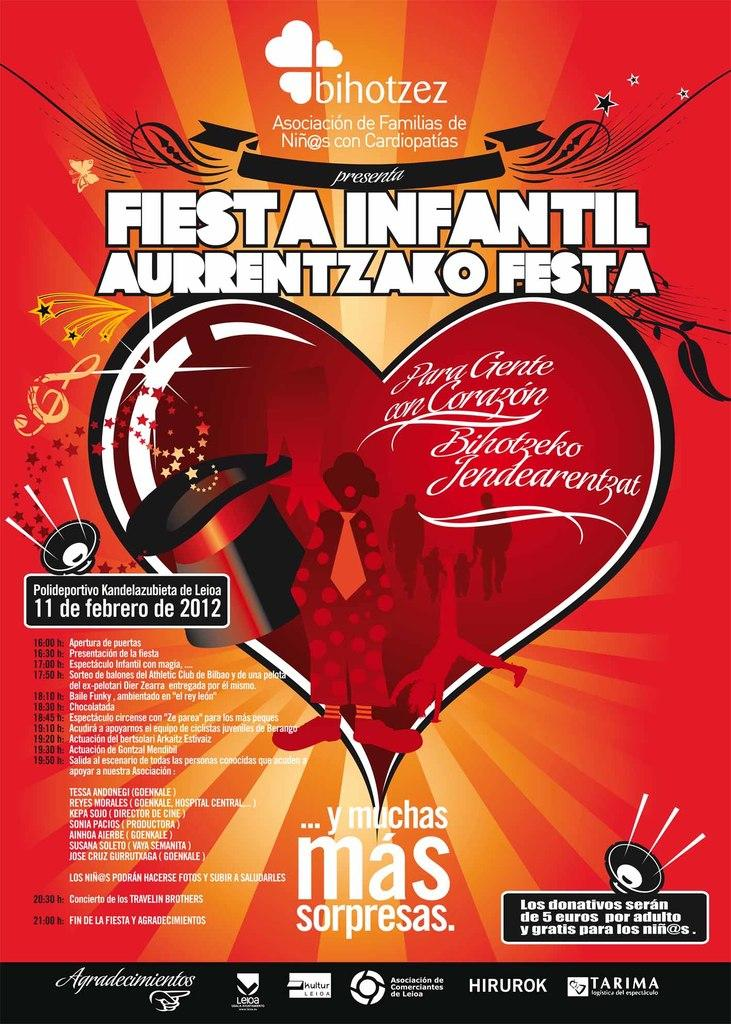<image>
Offer a succinct explanation of the picture presented. An advertisement advertises an event on February 11. 